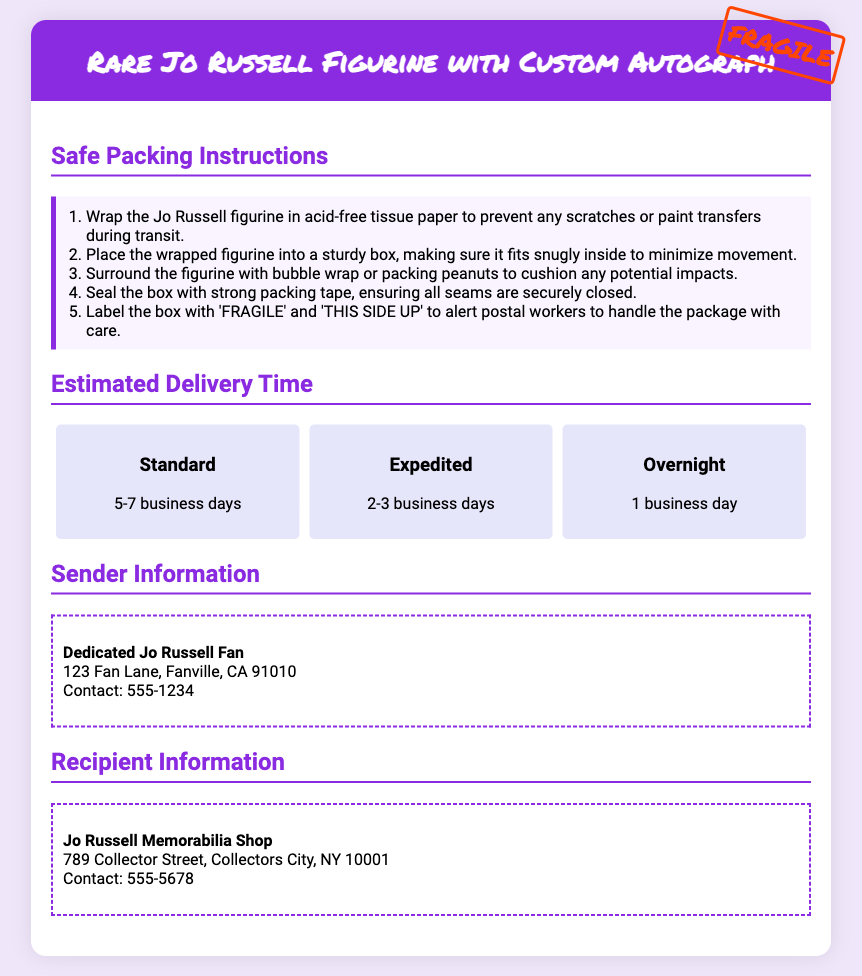What is the title of the document? The title of the document is indicated at the top, stating the type and item being shipped.
Answer: Rare Jo Russell Figurine with Custom Autograph How many business days does standard delivery take? The document provides specific estimated delivery times for different options, including standard delivery.
Answer: 5-7 business days What is included in the safe packing instructions? The document lists detailed steps to safely pack the figurine to prevent damage during shipping.
Answer: Wrap in acid-free tissue paper Who is the sender of the package? The document specifies the sender information in a section dedicated to it.
Answer: Dedicated Jo Russell Fan What should be written on the box for handling instructions? The packing instructions include specific labels to help postal workers handle the package correctly.
Answer: FRAGILE and THIS SIDE UP What is the contact number for the recipient? The document lists the contact details for the recipient in a section dedicated to them.
Answer: 555-5678 How should the figurine be cushioned in the box? The packing instructions mention how to secure the figurine to avoid damage during shipment.
Answer: With bubble wrap or packing peanuts What is the fastest delivery option available? The document outlines several delivery options, including their time frames.
Answer: Overnight What type of paper should be used to wrap the figurine? The safe packing instructions specify the kind of paper to use to prevent damage.
Answer: Acid-free tissue paper 